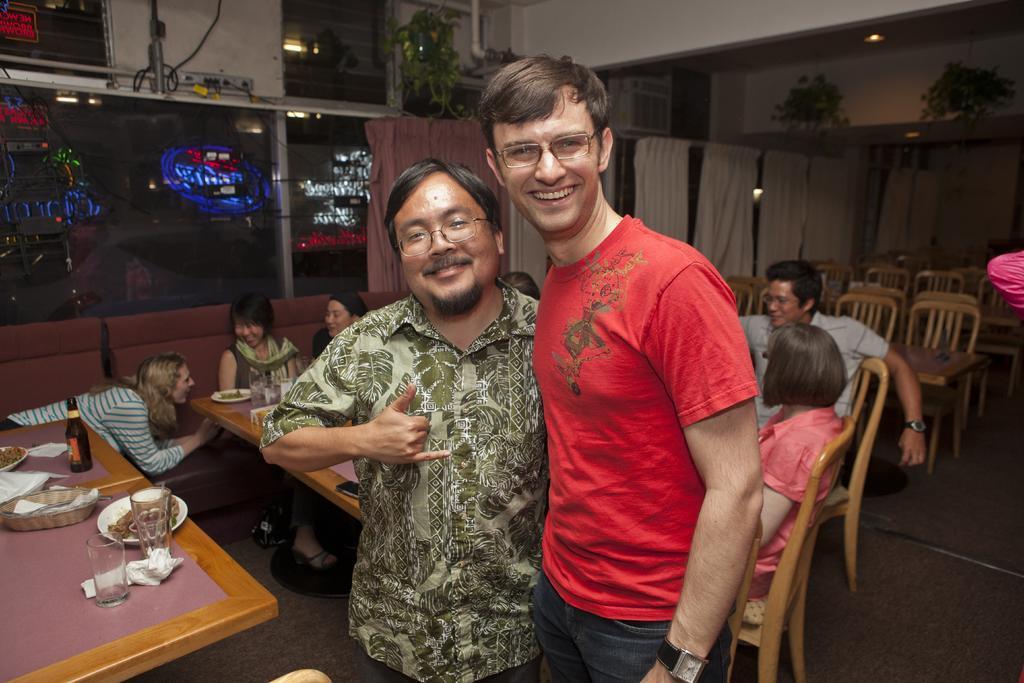Please provide a concise description of this image. This picture describe about the a inside view of the restaurant in which a group of people are sitting and enjoying the food. In front a boy wearing red t- shirt and jean is standing and giving the pose into the camera and smiling. Beside another Chinese man with beard is also standing and giving the pose into the camera. Behind we can see the curtain, some hanging plant pots and a big glass window from which road is seen. 